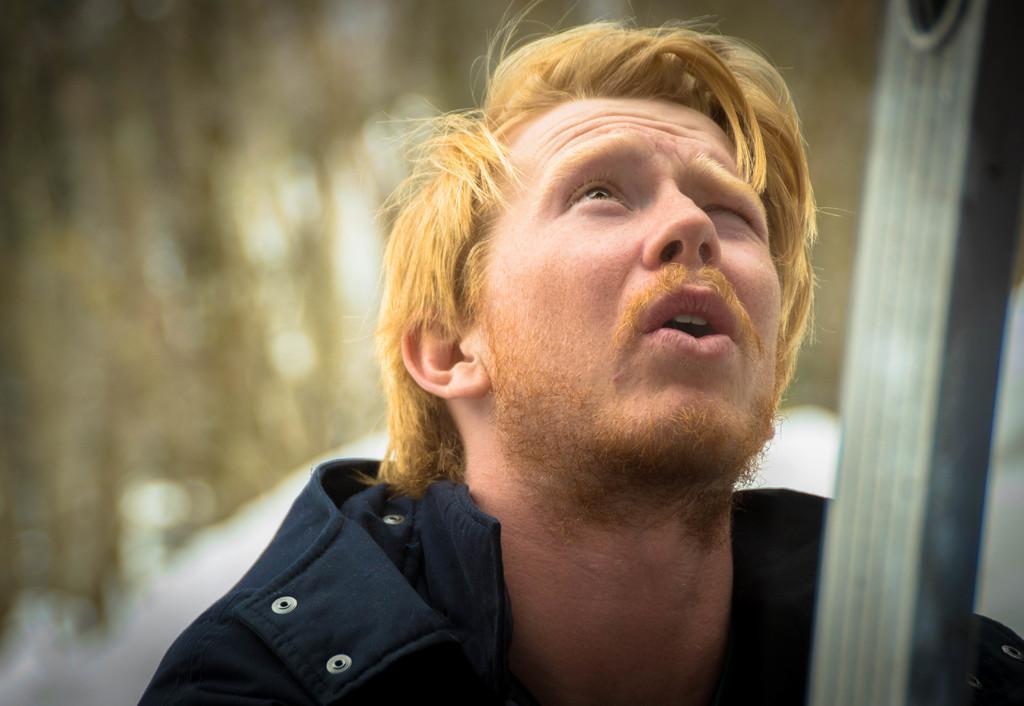Describe this image in one or two sentences. In this image we can see a man and an object. There is a blur background. 